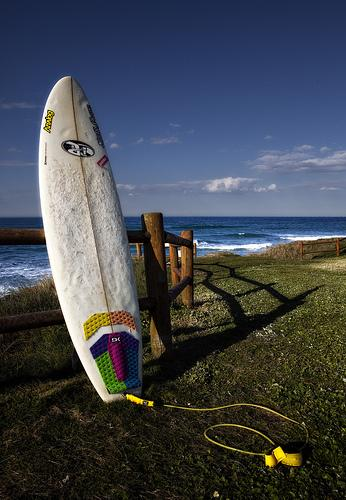Mention the main focal point of the image and some accompanying details. The image showcases a white surfboard, adorned with several stickers, leaning on a wooden fence near the ocean with light blue water and whitecaps from the waves. Describe the image's main focus and its backdrop in a creative way. Like a piece of art, a uniquely adorned surfboard leans on a wooden fence, the picturesque beach with its idyllic green grass and serene ocean waves serving as its living canvas. Provide a concise description of the core subject and its surroundings. A decorated surfboard is propped against a fence on a beachside, surrounded by a calming combination of green grass, blooming white flowers, and gently rolling ocean waves. Briefly describe the main object and its setting in a picturesque manner. A white surfboard adorned with various hues and patterns rests gracefully against a rustic wooden fence, basking in the charming coastal scenery of grassy sands and gentle waves. Describe the central object and the surrounding environment in simple terms. There is a surfboard with various colors and patterns leaning on a fence by the sea, with grass, flowers, and waves in the background. In one sentence, mention the central item and its context. The image portrays a surfboard with an assortment of colors and designs leaning on a wooden fence near a grassy beach and a peaceful ocean. Provide an overview of the primary subject and its immediate location. A white surfboard featuring colorful padding and a black and white pattern leans against a brown wooden fence at a beach with green grass and ocean waves nearby. Provide a brief description of the prominent object and its surroundings. A white surfboard with multicolored padding and black and white pattern is leaning against a wooden fence on a beach surrounded by green grass and white flowers. Write a simple statement describing the primary object and its location. A surfboard with colorful details stands against a wooden fence on a beach near the ocean. Express the key elements of the image in a poetic manner. A vibrantly embellished surfboard leans gracefully against an old fence, caught in a timeless embrace between the earth's green caresses and the ocean's gentle whispers. 